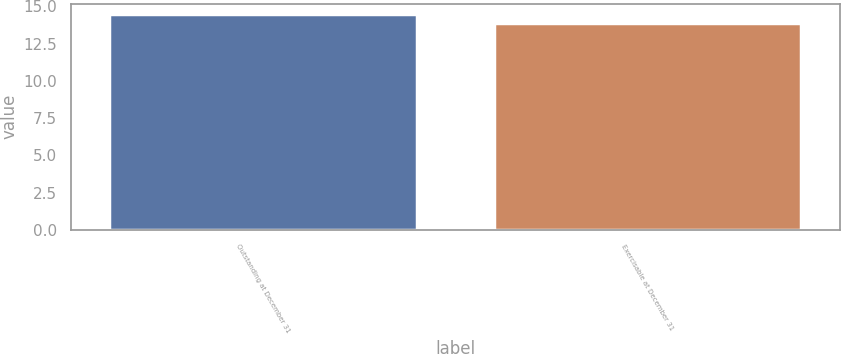Convert chart to OTSL. <chart><loc_0><loc_0><loc_500><loc_500><bar_chart><fcel>Outstanding at December 31<fcel>Exercisable at December 31<nl><fcel>14.47<fcel>13.87<nl></chart> 